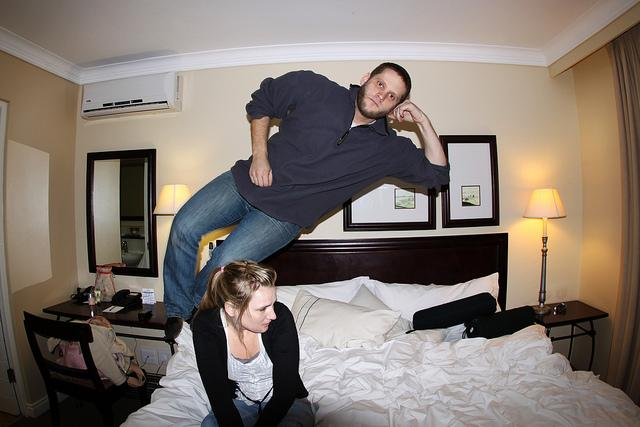Why does the man stand so strangely here? Please explain your reasoning. posing. The man is posing. 